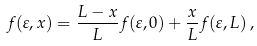<formula> <loc_0><loc_0><loc_500><loc_500>f ( \varepsilon , x ) = \frac { L - x } { L } f ( \varepsilon , 0 ) + \frac { x } { L } f ( \varepsilon , L ) \, ,</formula> 